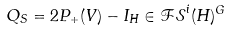Convert formula to latex. <formula><loc_0><loc_0><loc_500><loc_500>Q _ { S } = 2 P _ { + } ( V ) - I _ { H } \in \mathcal { F S } ^ { i } ( H ) ^ { G }</formula> 